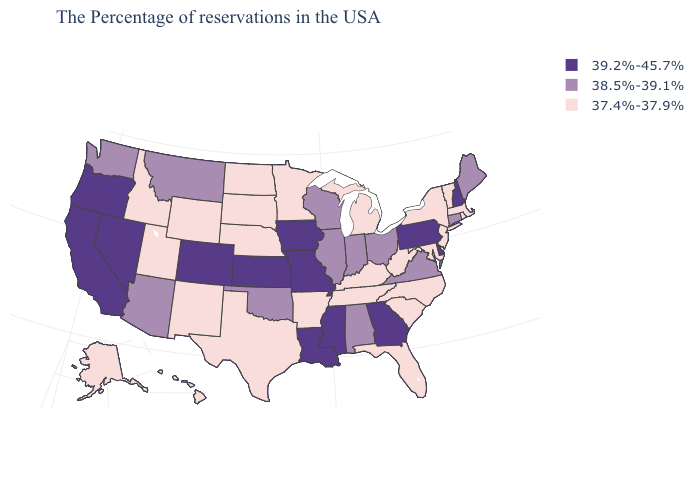Among the states that border Vermont , which have the lowest value?
Be succinct. Massachusetts, New York. Name the states that have a value in the range 38.5%-39.1%?
Quick response, please. Maine, Connecticut, Virginia, Ohio, Indiana, Alabama, Wisconsin, Illinois, Oklahoma, Montana, Arizona, Washington. Among the states that border Kentucky , which have the lowest value?
Answer briefly. West Virginia, Tennessee. What is the value of West Virginia?
Write a very short answer. 37.4%-37.9%. Name the states that have a value in the range 37.4%-37.9%?
Write a very short answer. Massachusetts, Rhode Island, Vermont, New York, New Jersey, Maryland, North Carolina, South Carolina, West Virginia, Florida, Michigan, Kentucky, Tennessee, Arkansas, Minnesota, Nebraska, Texas, South Dakota, North Dakota, Wyoming, New Mexico, Utah, Idaho, Alaska, Hawaii. Does Indiana have the same value as Delaware?
Give a very brief answer. No. Which states hav the highest value in the Northeast?
Short answer required. New Hampshire, Pennsylvania. What is the value of Utah?
Quick response, please. 37.4%-37.9%. Which states have the highest value in the USA?
Keep it brief. New Hampshire, Delaware, Pennsylvania, Georgia, Mississippi, Louisiana, Missouri, Iowa, Kansas, Colorado, Nevada, California, Oregon. What is the value of Arizona?
Give a very brief answer. 38.5%-39.1%. Does the first symbol in the legend represent the smallest category?
Concise answer only. No. Name the states that have a value in the range 38.5%-39.1%?
Short answer required. Maine, Connecticut, Virginia, Ohio, Indiana, Alabama, Wisconsin, Illinois, Oklahoma, Montana, Arizona, Washington. Does Arizona have the lowest value in the USA?
Write a very short answer. No. What is the value of Maine?
Be succinct. 38.5%-39.1%. What is the highest value in the USA?
Answer briefly. 39.2%-45.7%. 